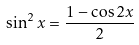<formula> <loc_0><loc_0><loc_500><loc_500>\sin ^ { 2 } x = \frac { 1 - \cos 2 x } { 2 }</formula> 